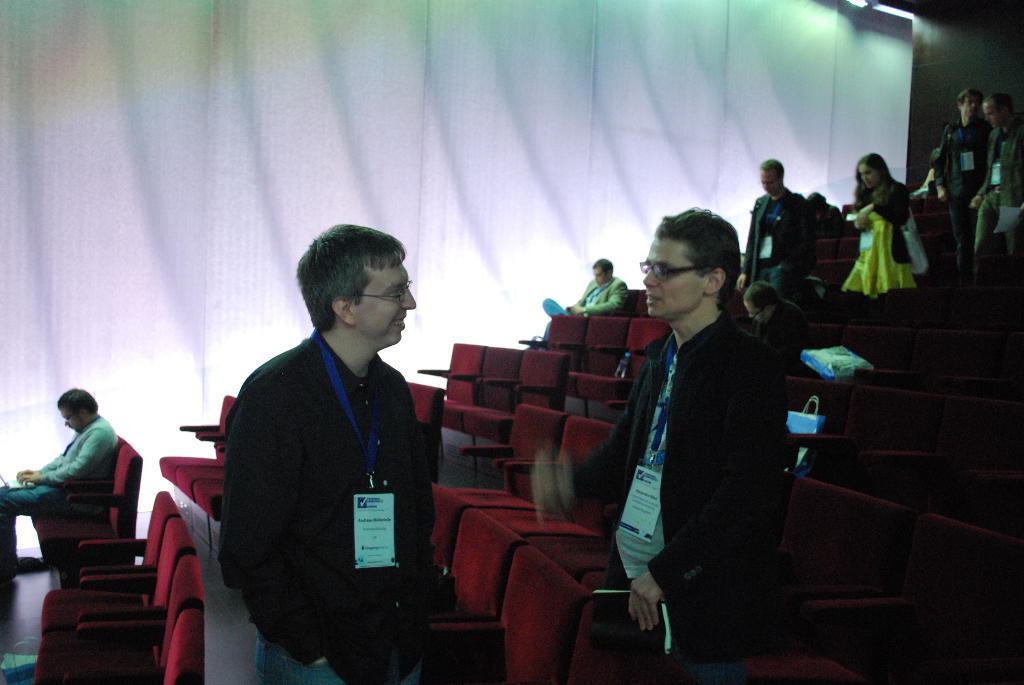Describe this image in one or two sentences. In the background we can see the white backdrop. We can see people, among them few are sitting on the chairs, few were identity cards and few are standing. We can see bags on the chairs. It seems like a movie theater. 